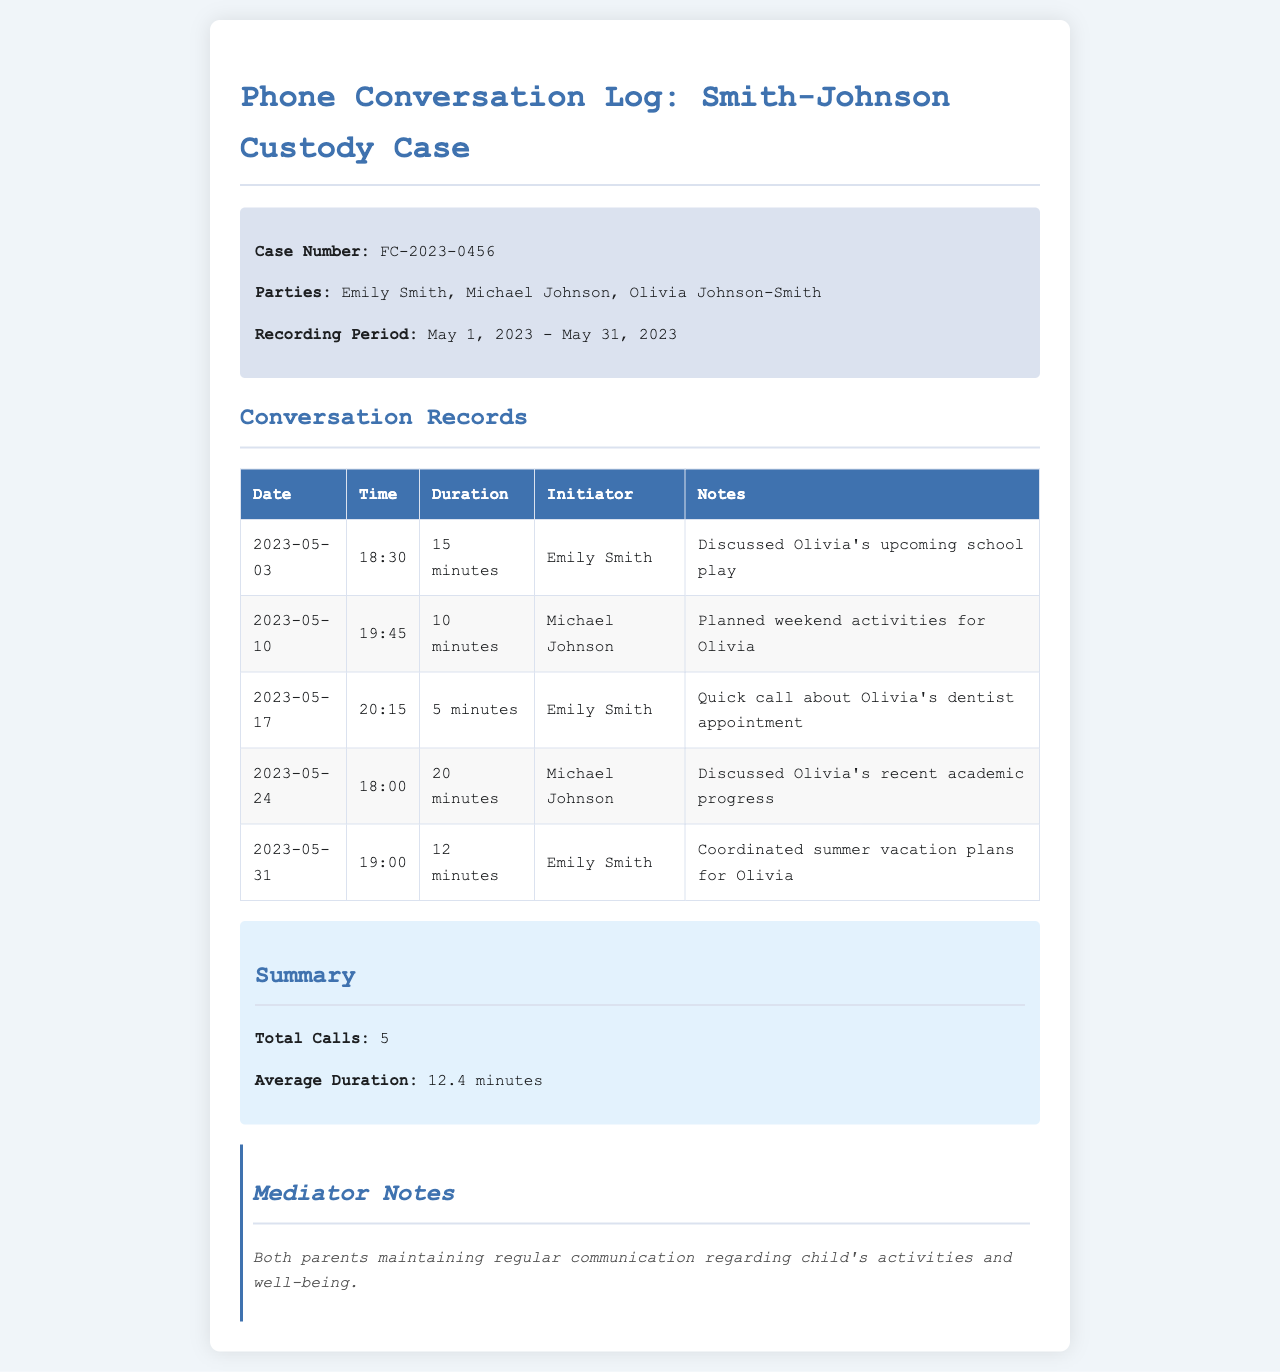what is the case number? The case number is listed in the document under case information.
Answer: FC-2023-0456 who is the initiator of the call on May 10, 2023? The initiator is provided in each record of the conversation log.
Answer: Michael Johnson how many total calls were made? The total number of calls is summarized at the end of the document.
Answer: 5 what was discussed during the call on May 24, 2023? The notes for each call provide specific discussion topics.
Answer: Olivia's recent academic progress what is the average duration of the calls? The average duration is calculated and provided in the summary section.
Answer: 12.4 minutes who discussed Olivia's school play? The document contains details of each caller related to specific discussions.
Answer: Emily Smith how long was the call on May 17, 2023? Call durations are listed chronologically in the conversation records.
Answer: 5 minutes when did Emily Smith coordinate summer vacation plans for Olivia? The date of the specific call is included in each conversation record.
Answer: May 31, 2023 which parent called at 18:30 on May 3, 2023? The initiator column specifies which parent made the call on that date and time.
Answer: Emily Smith 